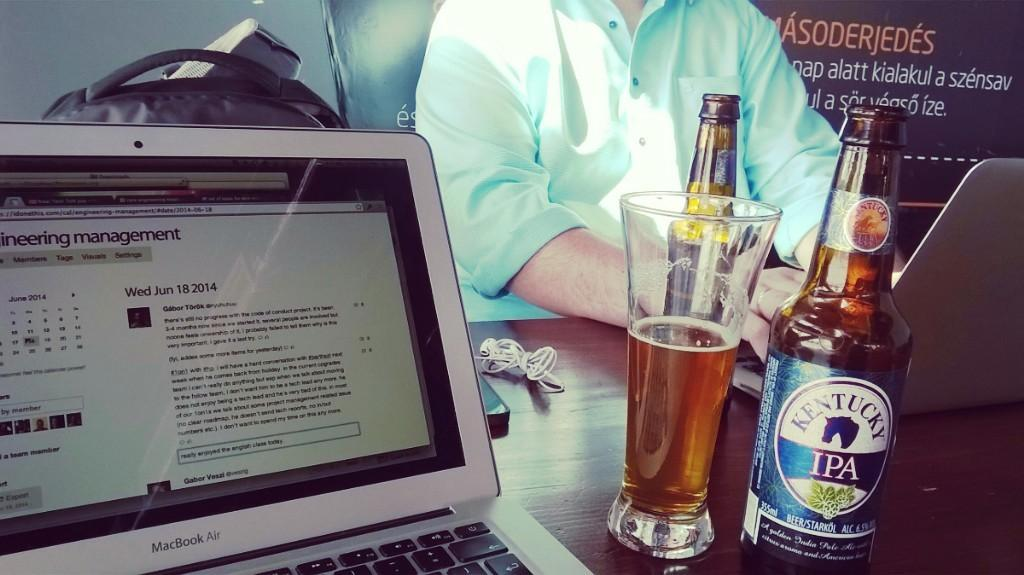<image>
Present a compact description of the photo's key features. a glass and bottle of Kentucky IPA on a computer table 